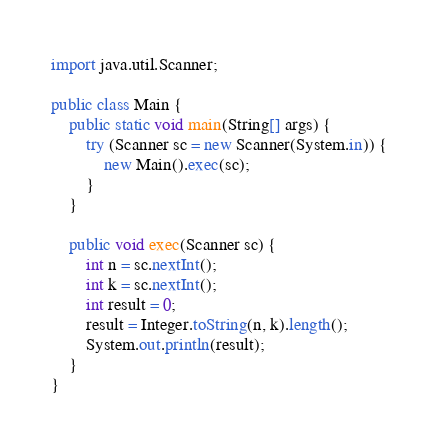Convert code to text. <code><loc_0><loc_0><loc_500><loc_500><_Java_>import java.util.Scanner;

public class Main {
	public static void main(String[] args) {
		try (Scanner sc = new Scanner(System.in)) {
			new Main().exec(sc);
		}
	}

	public void exec(Scanner sc) {
		int n = sc.nextInt();
		int k = sc.nextInt();
		int result = 0;
		result = Integer.toString(n, k).length();
		System.out.println(result);
	}
}
</code> 